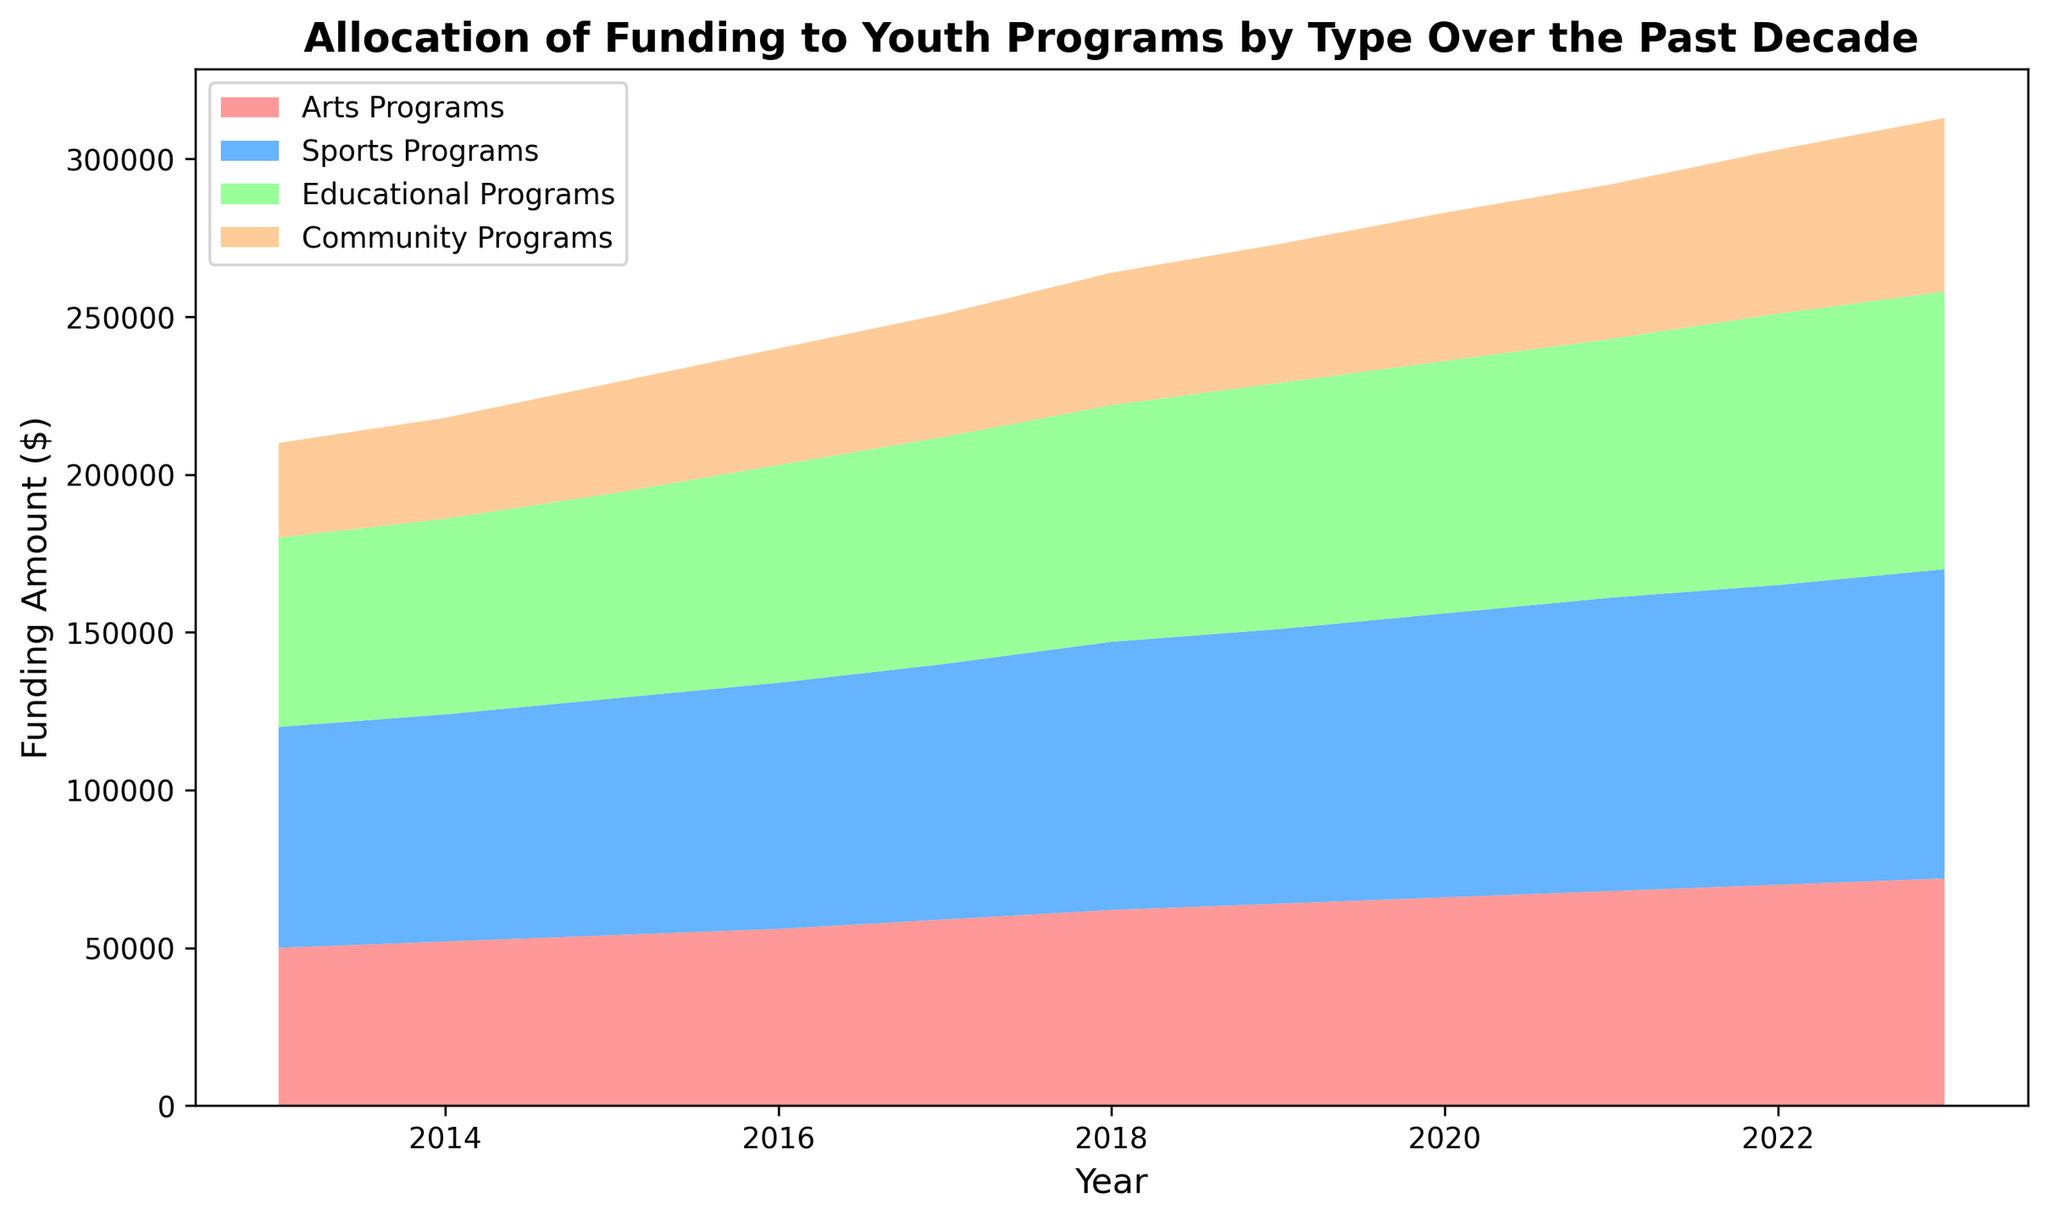What type of program received the highest funding in 2023? By observing the figure, the highest area stack for 2023 corresponds to the Sports Programs category, which visually appears to have the highest funding.
Answer: Sports Programs How did funding for Community Programs change from 2013 to 2023? To determine the change in funding, compare the starting and ending values for Community Programs. It started at $30,000 in 2013 and reached $55,000 in 2023, thus increasing by $25,000.
Answer: Increased by $25,000 Which type of program saw the most significant increase in funding over the decade? Compare the funding for each program type between 2013 and 2023. Arts Programs increased by $22,000, Sports Programs by $28,000, Educational Programs by $28,000, and Community Programs by $25,000. Sports and Educational Programs both increased the most.
Answer: Sports Programs and Educational Programs In which year did Sports Programs funding surpass $80,000? By examining the plot, the Sports Programs funding surpasses the $80,000 mark between 2017 and 2018. Specifically, in 2018, it reaches $85,000.
Answer: 2018 What is the total combined funding for all types of programs in 2020? Sum the funding amounts for Arts Programs, Sports Programs, Educational Programs, and Community Programs in 2020: (66,000 + 90,000 + 80,000 + 47,000) = 283,000.
Answer: $283,000 Which program showed the steadier growth over the decade? By assessing the plot, all programs exhibit fairly steady growth; however, Educational Programs show a consistent upward trend without sudden increases or jumps, indicating steadier growth.
Answer: Educational Programs What visual patterns are noticeable in the funding allocation trends over the decade? The plot reveals that all types of programs exhibit an upward trend in funding allocation, with each program consistently growing each year. There is no year where a program's funding decreases, indicating continuous growth across all categories.
Answer: Continuous growth across all categories How does the funding trend for Educational Programs compare to that for Sports Programs from 2015 to 2020? By analyzing the areas of the plot between 2015 and 2020 for both categories, Educational Programs show a consistent upward trend, but Sports Programs not only follow this trend but also experience a faster rate of increase in this period.
Answer: Sports Programs increased faster In which year did funding for Educational Programs first reach $80,000? According to the plot, Educational Programs funding reaches the $80,000 mark in the year 2020.
Answer: 2020 